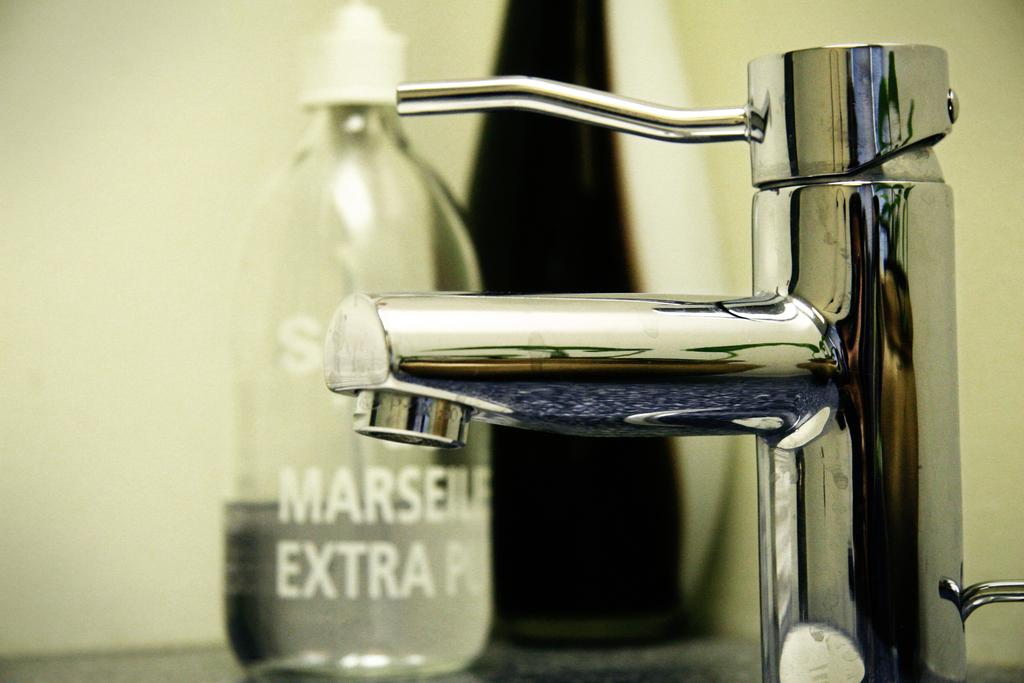<image>
Give a short and clear explanation of the subsequent image. A bottle of Marseile Extra is sitting next to a water faucet. 